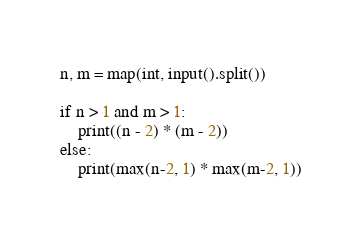<code> <loc_0><loc_0><loc_500><loc_500><_Python_>n, m = map(int, input().split())

if n > 1 and m > 1:
    print((n - 2) * (m - 2))
else:
    print(max(n-2, 1) * max(m-2, 1))</code> 